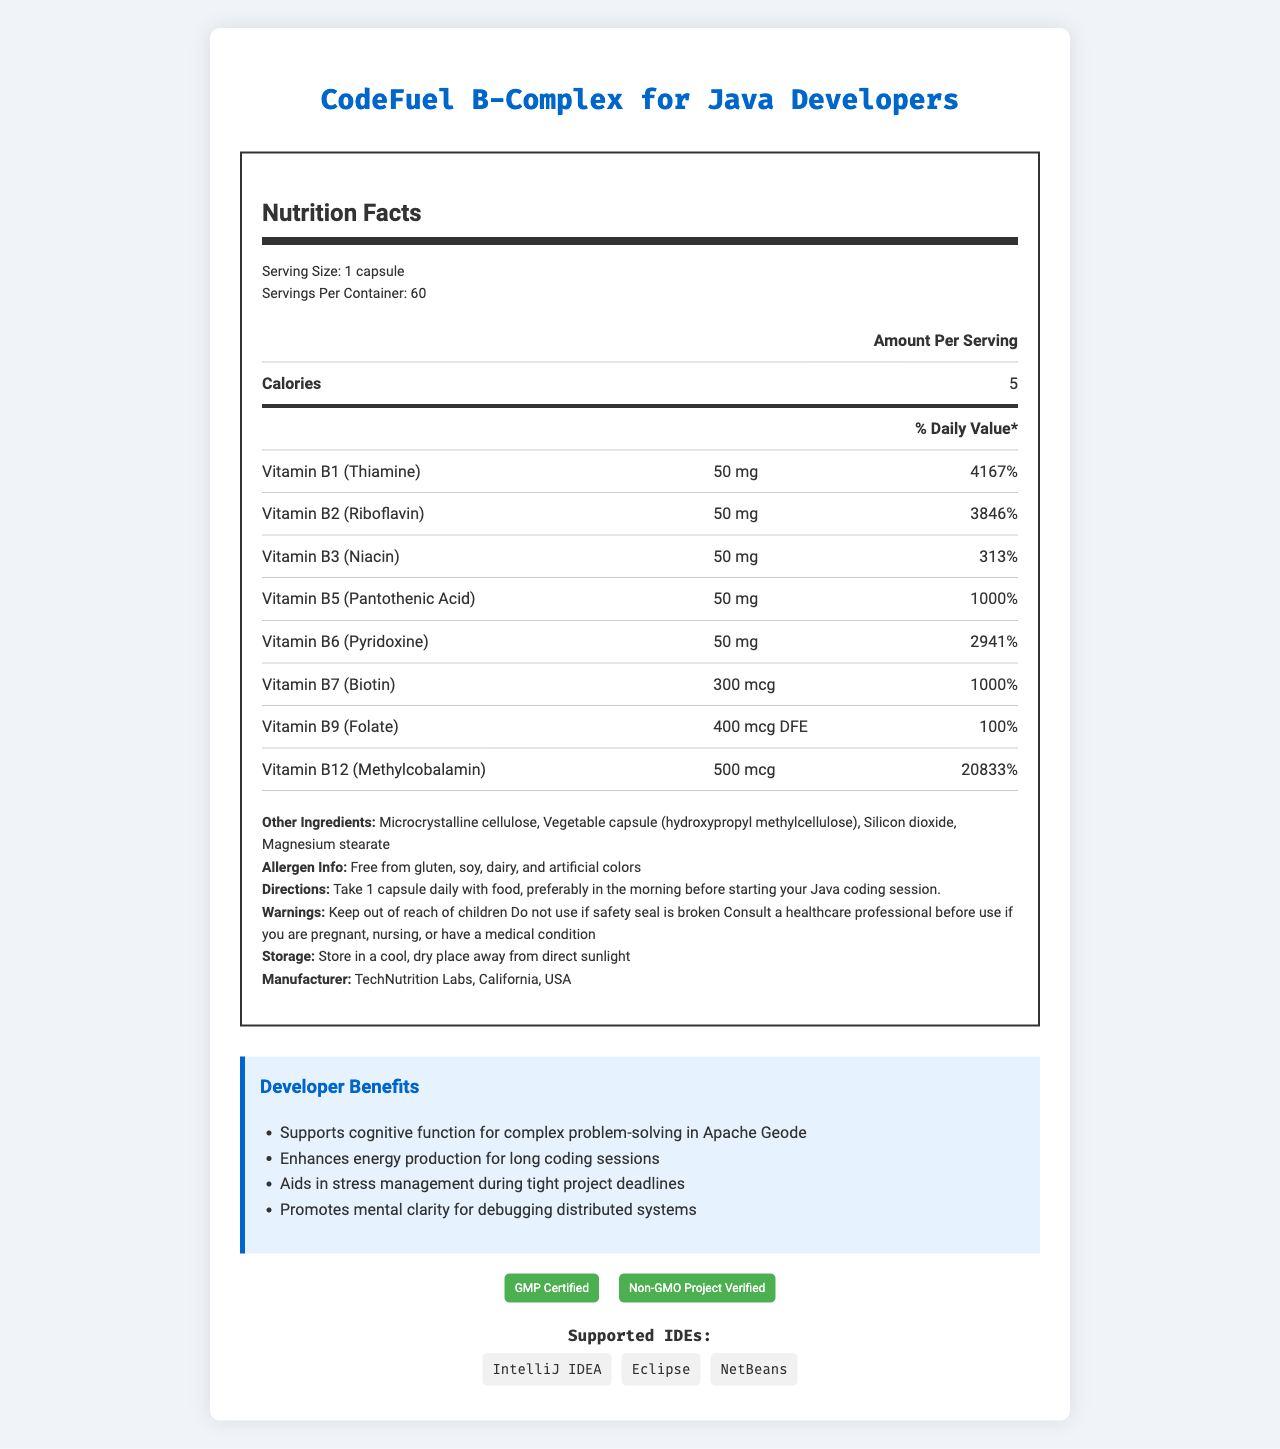what is the serving size? The serving size is explicitly mentioned in the "serving info" section of the document as "1 capsule".
Answer: 1 capsule how many servings are there per container? The number of servings per container is stated in the "serving info" section as "Servings Per Container: 60".
Answer: 60 how many calories are in one serving? The calories per serving are mentioned in the table of the "nutrition label" as "Calories: 5".
Answer: 5 which vitamin has the highest percentage of daily value? Vitamin B12 has the highest daily value percentage listed as 20833% in the nutrients table.
Answer: Vitamin B12 (Methylcobalamin) what are the other ingredients in this supplement? The "other ingredients" are listed right under the nutrients table in the "other-info" section of the document.
Answer: Microcrystalline cellulose, Vegetable capsule (hydroxypropyl methylcellulose), Silicon dioxide, Magnesium stearate what should you do if the safety seal is broken? A. Use it cautiously B. Consult a healthcare professional C. Do not use it In the "warnings" section, it is clearly stated "Do not use if the safety seal is broken".
Answer: C which of the following certifications does this product boast? I. GMP Certified II. Organic Certified III. Non-GMO Project Verified IV. Kosher Certified Both "GMP Certified" and "Non-GMO Project Verified" certifications are listed in the "certifications" section of the document.
Answer: I & III is this supplement free from gluten and dairy? The "allergen info" section explicitly states it is "Free from gluten, soy, dairy, and artificial colors".
Answer: Yes summarize the main benefits of the "CodeFuel B-Complex for Java Developers". The supplement is formulated specifically for the needs of Java developers, emphasizing cognitive support and stress management while providing necessary energy and mental clarity for their rigorous tasks.
Answer: The CodeFuel B-Complex supplement is tailored to enhance the mental clarity, cognitive function, and stress management of Java developers. It supports complex problem-solving, provides energy for extended coding sessions, aids in stress management during tight deadlines, and promotes mental clarity for debugging distributed systems. how should the supplement be stored? The storage instructions in the "other-info" section suggest storing it in a cool, dry place away from direct sunlight.
Answer: In a cool, dry place away from direct sunlight can this document help me understand how Apache Geode works? The document focuses solely on the nutrition facts and developer benefits of the supplement. It does not provide any information on how Apache Geode works.
Answer: Cannot be determined 